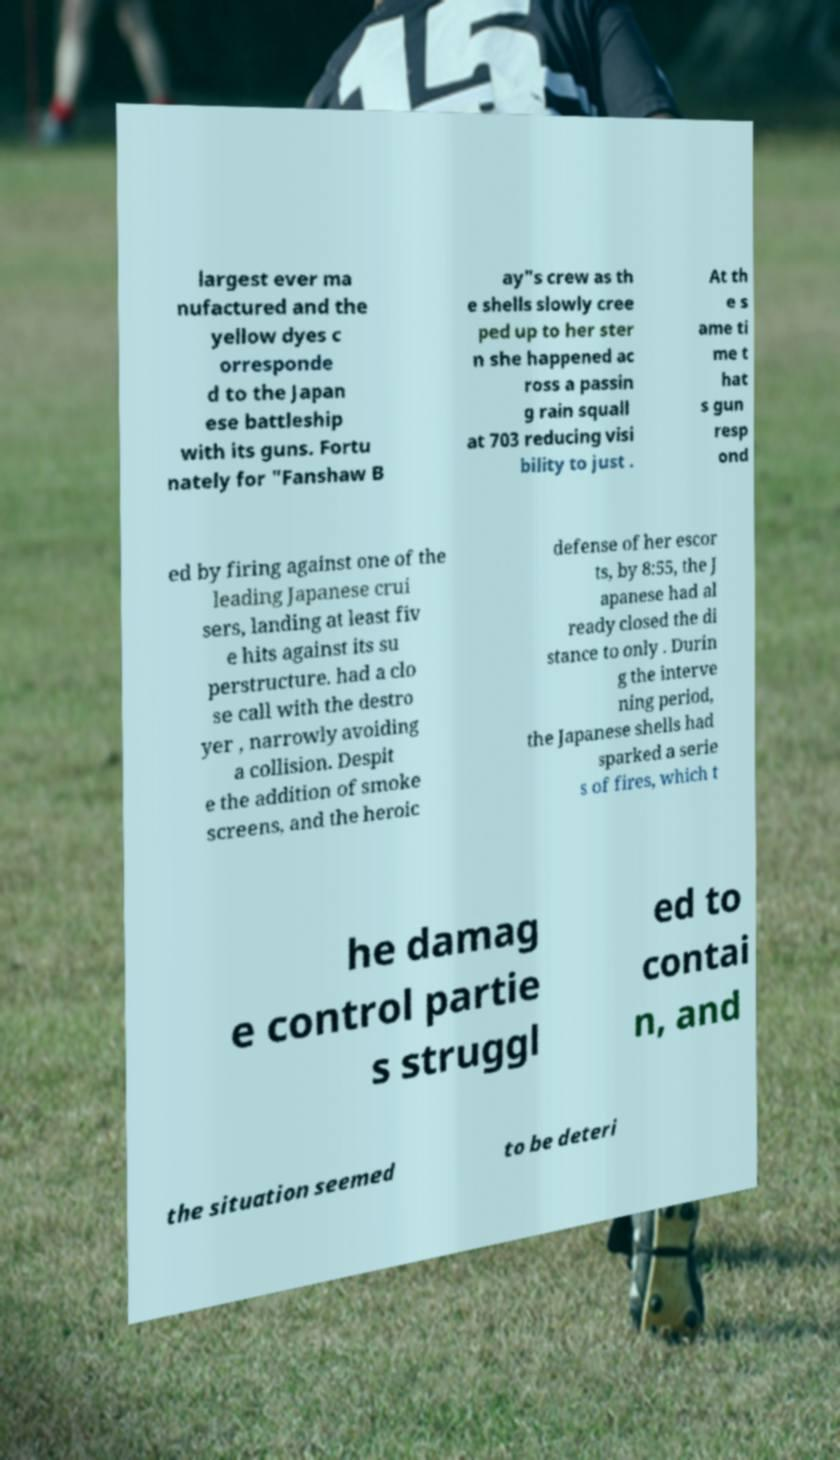I need the written content from this picture converted into text. Can you do that? largest ever ma nufactured and the yellow dyes c orresponde d to the Japan ese battleship with its guns. Fortu nately for "Fanshaw B ay"s crew as th e shells slowly cree ped up to her ster n she happened ac ross a passin g rain squall at 703 reducing visi bility to just . At th e s ame ti me t hat s gun resp ond ed by firing against one of the leading Japanese crui sers, landing at least fiv e hits against its su perstructure. had a clo se call with the destro yer , narrowly avoiding a collision. Despit e the addition of smoke screens, and the heroic defense of her escor ts, by 8:55, the J apanese had al ready closed the di stance to only . Durin g the interve ning period, the Japanese shells had sparked a serie s of fires, which t he damag e control partie s struggl ed to contai n, and the situation seemed to be deteri 